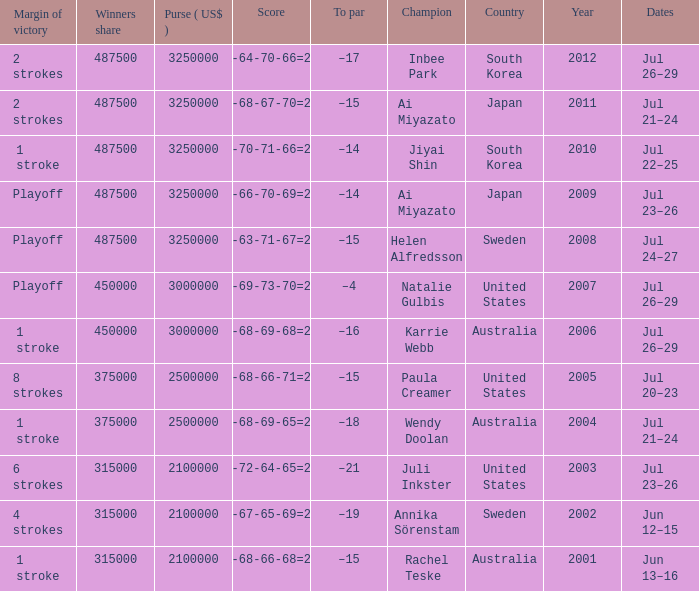Would you mind parsing the complete table? {'header': ['Margin of victory', 'Winners share', 'Purse ( US$ )', 'Score', 'To par', 'Champion', 'Country', 'Year', 'Dates'], 'rows': [['2 strokes', '487500', '3250000', '71-64-70-66=271', '–17', 'Inbee Park', 'South Korea', '2012', 'Jul 26–29'], ['2 strokes', '487500', '3250000', '68-68-67-70=273', '–15', 'Ai Miyazato', 'Japan', '2011', 'Jul 21–24'], ['1 stroke', '487500', '3250000', '68-70-71-66=274', '–14', 'Jiyai Shin', 'South Korea', '2010', 'Jul 22–25'], ['Playoff', '487500', '3250000', '69-66-70-69=274', '–14', 'Ai Miyazato', 'Japan', '2009', 'Jul 23–26'], ['Playoff', '487500', '3250000', '72-63-71-67=273', '–15', 'Helen Alfredsson', 'Sweden', '2008', 'Jul 24–27'], ['Playoff', '450000', '3000000', '72-69-73-70=284', '–4', 'Natalie Gulbis', 'United States', '2007', 'Jul 26–29'], ['1 stroke', '450000', '3000000', '67-68-69-68=272', '–16', 'Karrie Webb', 'Australia', '2006', 'Jul 26–29'], ['8 strokes', '375000', '2500000', '68-68-66-71=273', '–15', 'Paula Creamer', 'United States', '2005', 'Jul 20–23'], ['1 stroke', '375000', '2500000', '68-68-69-65=270', '–18', 'Wendy Doolan', 'Australia', '2004', 'Jul 21–24'], ['6 strokes', '315000', '2100000', '66-72-64-65=267', '–21', 'Juli Inkster', 'United States', '2003', 'Jul 23–26'], ['4 strokes', '315000', '2100000', '68-67-65-69=269', '–19', 'Annika Sörenstam', 'Sweden', '2002', 'Jun 12–15'], ['1 stroke', '315000', '2100000', '71-68-66-68=273', '–15', 'Rachel Teske', 'Australia', '2001', 'Jun 13–16']]} What is the lowest year listed? 2001.0. 